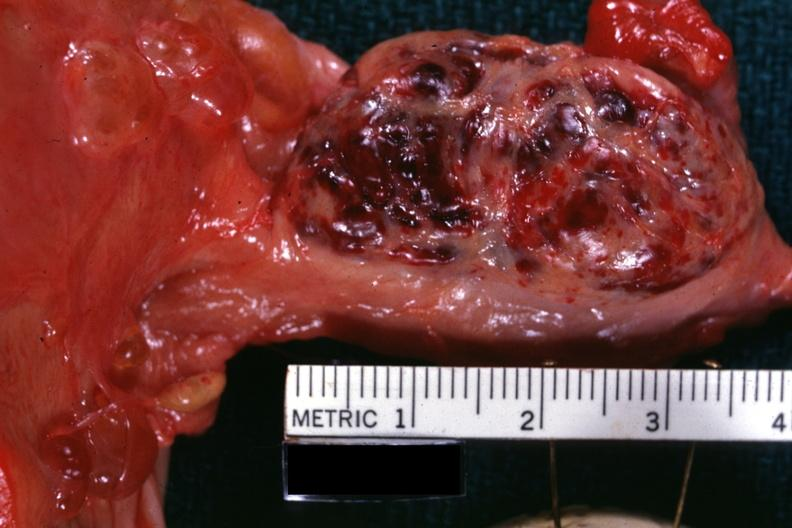s female reproductive present?
Answer the question using a single word or phrase. Yes 